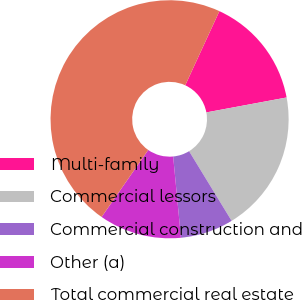Convert chart. <chart><loc_0><loc_0><loc_500><loc_500><pie_chart><fcel>Multi-family<fcel>Commercial lessors<fcel>Commercial construction and<fcel>Other (a)<fcel>Total commercial real estate<nl><fcel>15.2%<fcel>19.2%<fcel>7.2%<fcel>11.2%<fcel>47.19%<nl></chart> 